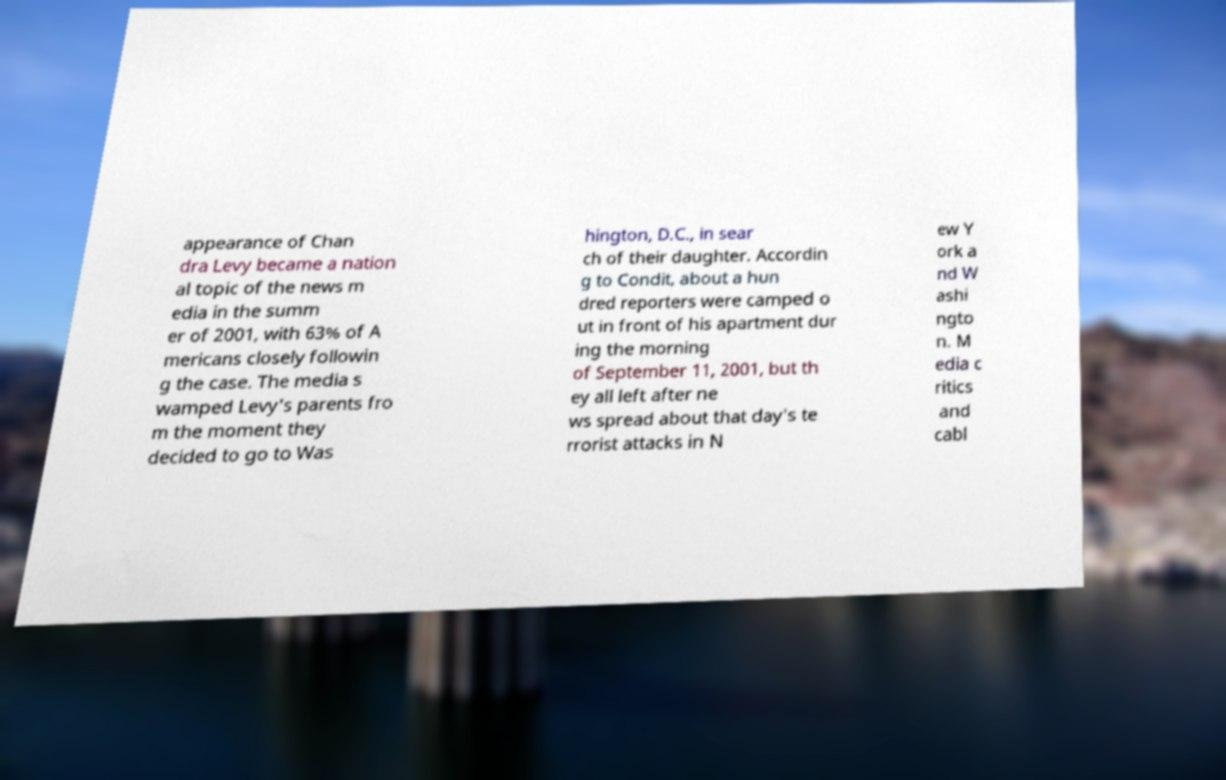Can you accurately transcribe the text from the provided image for me? appearance of Chan dra Levy became a nation al topic of the news m edia in the summ er of 2001, with 63% of A mericans closely followin g the case. The media s wamped Levy's parents fro m the moment they decided to go to Was hington, D.C., in sear ch of their daughter. Accordin g to Condit, about a hun dred reporters were camped o ut in front of his apartment dur ing the morning of September 11, 2001, but th ey all left after ne ws spread about that day's te rrorist attacks in N ew Y ork a nd W ashi ngto n. M edia c ritics and cabl 